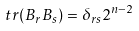<formula> <loc_0><loc_0><loc_500><loc_500>t r ( B _ { r } B _ { s } ) = \delta _ { r s } 2 ^ { n - 2 }</formula> 